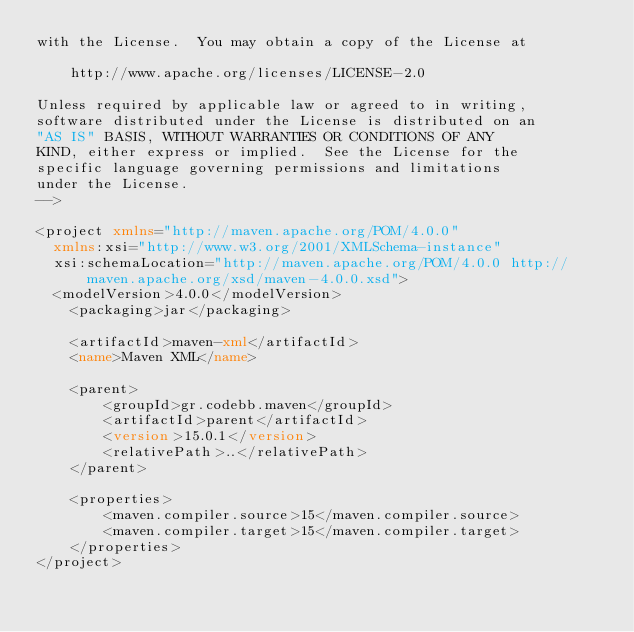<code> <loc_0><loc_0><loc_500><loc_500><_XML_>with the License.  You may obtain a copy of the License at

    http://www.apache.org/licenses/LICENSE-2.0

Unless required by applicable law or agreed to in writing,
software distributed under the License is distributed on an
"AS IS" BASIS, WITHOUT WARRANTIES OR CONDITIONS OF ANY
KIND, either express or implied.  See the License for the
specific language governing permissions and limitations
under the License.
-->

<project xmlns="http://maven.apache.org/POM/4.0.0"
  xmlns:xsi="http://www.w3.org/2001/XMLSchema-instance"
  xsi:schemaLocation="http://maven.apache.org/POM/4.0.0 http://maven.apache.org/xsd/maven-4.0.0.xsd">
  <modelVersion>4.0.0</modelVersion>
    <packaging>jar</packaging>

    <artifactId>maven-xml</artifactId>
    <name>Maven XML</name>

    <parent>
        <groupId>gr.codebb.maven</groupId>
        <artifactId>parent</artifactId>
        <version>15.0.1</version>
        <relativePath>..</relativePath>
    </parent>

    <properties>
        <maven.compiler.source>15</maven.compiler.source>
        <maven.compiler.target>15</maven.compiler.target>
    </properties>
</project></code> 